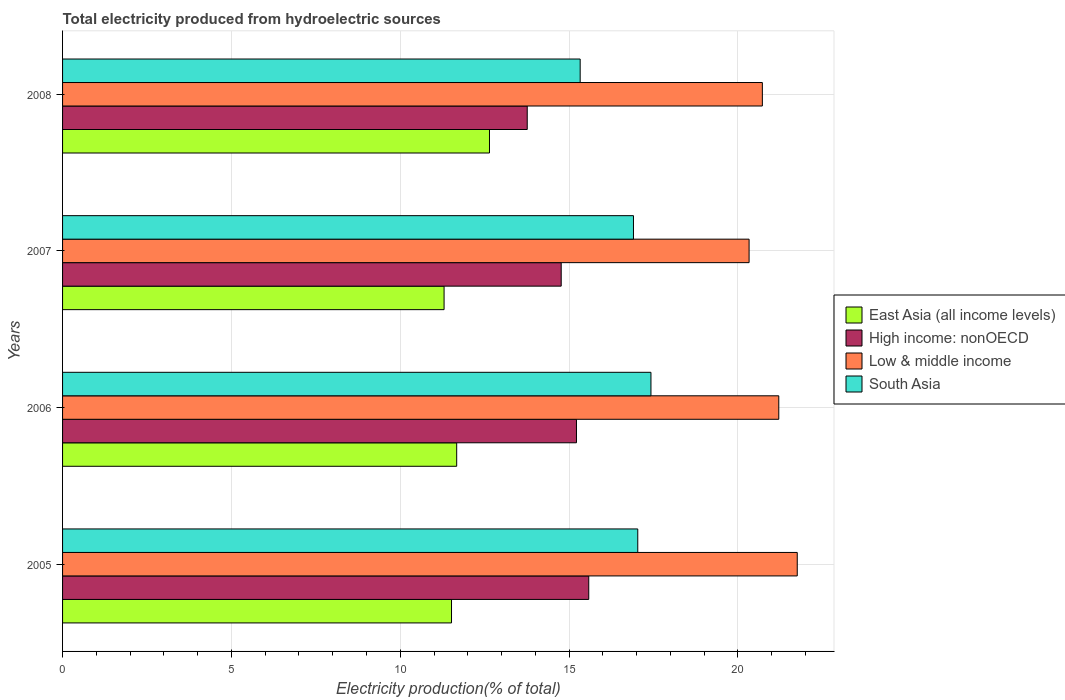How many different coloured bars are there?
Make the answer very short. 4. Are the number of bars per tick equal to the number of legend labels?
Provide a short and direct response. Yes. How many bars are there on the 4th tick from the top?
Keep it short and to the point. 4. How many bars are there on the 4th tick from the bottom?
Make the answer very short. 4. What is the label of the 4th group of bars from the top?
Your answer should be compact. 2005. In how many cases, is the number of bars for a given year not equal to the number of legend labels?
Keep it short and to the point. 0. What is the total electricity produced in South Asia in 2007?
Your answer should be compact. 16.91. Across all years, what is the maximum total electricity produced in South Asia?
Give a very brief answer. 17.43. Across all years, what is the minimum total electricity produced in Low & middle income?
Your answer should be compact. 20.33. In which year was the total electricity produced in Low & middle income maximum?
Ensure brevity in your answer.  2005. In which year was the total electricity produced in High income: nonOECD minimum?
Make the answer very short. 2008. What is the total total electricity produced in South Asia in the graph?
Ensure brevity in your answer.  66.7. What is the difference between the total electricity produced in East Asia (all income levels) in 2005 and that in 2006?
Ensure brevity in your answer.  -0.15. What is the difference between the total electricity produced in High income: nonOECD in 2006 and the total electricity produced in East Asia (all income levels) in 2005?
Provide a succinct answer. 3.7. What is the average total electricity produced in East Asia (all income levels) per year?
Make the answer very short. 11.78. In the year 2005, what is the difference between the total electricity produced in South Asia and total electricity produced in East Asia (all income levels)?
Make the answer very short. 5.52. In how many years, is the total electricity produced in Low & middle income greater than 13 %?
Provide a succinct answer. 4. What is the ratio of the total electricity produced in East Asia (all income levels) in 2005 to that in 2008?
Keep it short and to the point. 0.91. Is the total electricity produced in High income: nonOECD in 2007 less than that in 2008?
Make the answer very short. No. What is the difference between the highest and the second highest total electricity produced in Low & middle income?
Your answer should be compact. 0.55. What is the difference between the highest and the lowest total electricity produced in High income: nonOECD?
Offer a very short reply. 1.82. Is it the case that in every year, the sum of the total electricity produced in East Asia (all income levels) and total electricity produced in High income: nonOECD is greater than the sum of total electricity produced in South Asia and total electricity produced in Low & middle income?
Your response must be concise. Yes. What does the 4th bar from the top in 2005 represents?
Provide a short and direct response. East Asia (all income levels). How many bars are there?
Make the answer very short. 16. Are all the bars in the graph horizontal?
Provide a short and direct response. Yes. What is the difference between two consecutive major ticks on the X-axis?
Provide a succinct answer. 5. Are the values on the major ticks of X-axis written in scientific E-notation?
Provide a succinct answer. No. Where does the legend appear in the graph?
Your response must be concise. Center right. What is the title of the graph?
Keep it short and to the point. Total electricity produced from hydroelectric sources. What is the Electricity production(% of total) of East Asia (all income levels) in 2005?
Provide a succinct answer. 11.52. What is the Electricity production(% of total) in High income: nonOECD in 2005?
Make the answer very short. 15.58. What is the Electricity production(% of total) of Low & middle income in 2005?
Your answer should be very brief. 21.76. What is the Electricity production(% of total) in South Asia in 2005?
Offer a terse response. 17.04. What is the Electricity production(% of total) in East Asia (all income levels) in 2006?
Provide a short and direct response. 11.67. What is the Electricity production(% of total) of High income: nonOECD in 2006?
Offer a terse response. 15.22. What is the Electricity production(% of total) of Low & middle income in 2006?
Provide a succinct answer. 21.21. What is the Electricity production(% of total) of South Asia in 2006?
Offer a very short reply. 17.43. What is the Electricity production(% of total) of East Asia (all income levels) in 2007?
Give a very brief answer. 11.3. What is the Electricity production(% of total) of High income: nonOECD in 2007?
Provide a succinct answer. 14.77. What is the Electricity production(% of total) in Low & middle income in 2007?
Offer a very short reply. 20.33. What is the Electricity production(% of total) of South Asia in 2007?
Your answer should be very brief. 16.91. What is the Electricity production(% of total) of East Asia (all income levels) in 2008?
Keep it short and to the point. 12.64. What is the Electricity production(% of total) in High income: nonOECD in 2008?
Your answer should be compact. 13.76. What is the Electricity production(% of total) of Low & middle income in 2008?
Your answer should be very brief. 20.72. What is the Electricity production(% of total) in South Asia in 2008?
Provide a succinct answer. 15.33. Across all years, what is the maximum Electricity production(% of total) of East Asia (all income levels)?
Provide a succinct answer. 12.64. Across all years, what is the maximum Electricity production(% of total) in High income: nonOECD?
Give a very brief answer. 15.58. Across all years, what is the maximum Electricity production(% of total) in Low & middle income?
Provide a succinct answer. 21.76. Across all years, what is the maximum Electricity production(% of total) of South Asia?
Your answer should be compact. 17.43. Across all years, what is the minimum Electricity production(% of total) of East Asia (all income levels)?
Your response must be concise. 11.3. Across all years, what is the minimum Electricity production(% of total) of High income: nonOECD?
Provide a succinct answer. 13.76. Across all years, what is the minimum Electricity production(% of total) of Low & middle income?
Provide a succinct answer. 20.33. Across all years, what is the minimum Electricity production(% of total) in South Asia?
Your answer should be compact. 15.33. What is the total Electricity production(% of total) of East Asia (all income levels) in the graph?
Give a very brief answer. 47.13. What is the total Electricity production(% of total) in High income: nonOECD in the graph?
Offer a very short reply. 59.33. What is the total Electricity production(% of total) of Low & middle income in the graph?
Provide a succinct answer. 84.03. What is the total Electricity production(% of total) in South Asia in the graph?
Provide a short and direct response. 66.7. What is the difference between the Electricity production(% of total) of East Asia (all income levels) in 2005 and that in 2006?
Ensure brevity in your answer.  -0.15. What is the difference between the Electricity production(% of total) of High income: nonOECD in 2005 and that in 2006?
Your answer should be very brief. 0.36. What is the difference between the Electricity production(% of total) in Low & middle income in 2005 and that in 2006?
Your answer should be compact. 0.55. What is the difference between the Electricity production(% of total) of South Asia in 2005 and that in 2006?
Ensure brevity in your answer.  -0.39. What is the difference between the Electricity production(% of total) in East Asia (all income levels) in 2005 and that in 2007?
Offer a very short reply. 0.22. What is the difference between the Electricity production(% of total) in High income: nonOECD in 2005 and that in 2007?
Give a very brief answer. 0.82. What is the difference between the Electricity production(% of total) in Low & middle income in 2005 and that in 2007?
Provide a short and direct response. 1.43. What is the difference between the Electricity production(% of total) of South Asia in 2005 and that in 2007?
Your answer should be very brief. 0.13. What is the difference between the Electricity production(% of total) of East Asia (all income levels) in 2005 and that in 2008?
Your response must be concise. -1.12. What is the difference between the Electricity production(% of total) of High income: nonOECD in 2005 and that in 2008?
Offer a very short reply. 1.82. What is the difference between the Electricity production(% of total) in Low & middle income in 2005 and that in 2008?
Provide a short and direct response. 1.03. What is the difference between the Electricity production(% of total) of South Asia in 2005 and that in 2008?
Keep it short and to the point. 1.71. What is the difference between the Electricity production(% of total) in East Asia (all income levels) in 2006 and that in 2007?
Your response must be concise. 0.37. What is the difference between the Electricity production(% of total) of High income: nonOECD in 2006 and that in 2007?
Provide a short and direct response. 0.45. What is the difference between the Electricity production(% of total) of Low & middle income in 2006 and that in 2007?
Offer a terse response. 0.88. What is the difference between the Electricity production(% of total) in South Asia in 2006 and that in 2007?
Your response must be concise. 0.52. What is the difference between the Electricity production(% of total) in East Asia (all income levels) in 2006 and that in 2008?
Your answer should be very brief. -0.97. What is the difference between the Electricity production(% of total) in High income: nonOECD in 2006 and that in 2008?
Ensure brevity in your answer.  1.46. What is the difference between the Electricity production(% of total) of Low & middle income in 2006 and that in 2008?
Ensure brevity in your answer.  0.49. What is the difference between the Electricity production(% of total) in South Asia in 2006 and that in 2008?
Ensure brevity in your answer.  2.1. What is the difference between the Electricity production(% of total) in East Asia (all income levels) in 2007 and that in 2008?
Your answer should be compact. -1.34. What is the difference between the Electricity production(% of total) in High income: nonOECD in 2007 and that in 2008?
Offer a terse response. 1.01. What is the difference between the Electricity production(% of total) of Low & middle income in 2007 and that in 2008?
Ensure brevity in your answer.  -0.39. What is the difference between the Electricity production(% of total) in South Asia in 2007 and that in 2008?
Your response must be concise. 1.58. What is the difference between the Electricity production(% of total) of East Asia (all income levels) in 2005 and the Electricity production(% of total) of High income: nonOECD in 2006?
Keep it short and to the point. -3.7. What is the difference between the Electricity production(% of total) of East Asia (all income levels) in 2005 and the Electricity production(% of total) of Low & middle income in 2006?
Provide a short and direct response. -9.69. What is the difference between the Electricity production(% of total) in East Asia (all income levels) in 2005 and the Electricity production(% of total) in South Asia in 2006?
Your answer should be compact. -5.91. What is the difference between the Electricity production(% of total) of High income: nonOECD in 2005 and the Electricity production(% of total) of Low & middle income in 2006?
Your answer should be very brief. -5.63. What is the difference between the Electricity production(% of total) of High income: nonOECD in 2005 and the Electricity production(% of total) of South Asia in 2006?
Your response must be concise. -1.84. What is the difference between the Electricity production(% of total) of Low & middle income in 2005 and the Electricity production(% of total) of South Asia in 2006?
Offer a very short reply. 4.33. What is the difference between the Electricity production(% of total) in East Asia (all income levels) in 2005 and the Electricity production(% of total) in High income: nonOECD in 2007?
Provide a short and direct response. -3.25. What is the difference between the Electricity production(% of total) in East Asia (all income levels) in 2005 and the Electricity production(% of total) in Low & middle income in 2007?
Offer a very short reply. -8.81. What is the difference between the Electricity production(% of total) of East Asia (all income levels) in 2005 and the Electricity production(% of total) of South Asia in 2007?
Ensure brevity in your answer.  -5.39. What is the difference between the Electricity production(% of total) of High income: nonOECD in 2005 and the Electricity production(% of total) of Low & middle income in 2007?
Your answer should be very brief. -4.75. What is the difference between the Electricity production(% of total) of High income: nonOECD in 2005 and the Electricity production(% of total) of South Asia in 2007?
Your answer should be compact. -1.32. What is the difference between the Electricity production(% of total) of Low & middle income in 2005 and the Electricity production(% of total) of South Asia in 2007?
Keep it short and to the point. 4.85. What is the difference between the Electricity production(% of total) of East Asia (all income levels) in 2005 and the Electricity production(% of total) of High income: nonOECD in 2008?
Your response must be concise. -2.24. What is the difference between the Electricity production(% of total) of East Asia (all income levels) in 2005 and the Electricity production(% of total) of Low & middle income in 2008?
Provide a succinct answer. -9.21. What is the difference between the Electricity production(% of total) in East Asia (all income levels) in 2005 and the Electricity production(% of total) in South Asia in 2008?
Your answer should be compact. -3.81. What is the difference between the Electricity production(% of total) of High income: nonOECD in 2005 and the Electricity production(% of total) of Low & middle income in 2008?
Ensure brevity in your answer.  -5.14. What is the difference between the Electricity production(% of total) of High income: nonOECD in 2005 and the Electricity production(% of total) of South Asia in 2008?
Your answer should be compact. 0.25. What is the difference between the Electricity production(% of total) of Low & middle income in 2005 and the Electricity production(% of total) of South Asia in 2008?
Your answer should be compact. 6.43. What is the difference between the Electricity production(% of total) in East Asia (all income levels) in 2006 and the Electricity production(% of total) in High income: nonOECD in 2007?
Your response must be concise. -3.1. What is the difference between the Electricity production(% of total) in East Asia (all income levels) in 2006 and the Electricity production(% of total) in Low & middle income in 2007?
Keep it short and to the point. -8.66. What is the difference between the Electricity production(% of total) in East Asia (all income levels) in 2006 and the Electricity production(% of total) in South Asia in 2007?
Offer a terse response. -5.24. What is the difference between the Electricity production(% of total) of High income: nonOECD in 2006 and the Electricity production(% of total) of Low & middle income in 2007?
Keep it short and to the point. -5.11. What is the difference between the Electricity production(% of total) of High income: nonOECD in 2006 and the Electricity production(% of total) of South Asia in 2007?
Make the answer very short. -1.69. What is the difference between the Electricity production(% of total) in Low & middle income in 2006 and the Electricity production(% of total) in South Asia in 2007?
Provide a short and direct response. 4.3. What is the difference between the Electricity production(% of total) of East Asia (all income levels) in 2006 and the Electricity production(% of total) of High income: nonOECD in 2008?
Ensure brevity in your answer.  -2.09. What is the difference between the Electricity production(% of total) in East Asia (all income levels) in 2006 and the Electricity production(% of total) in Low & middle income in 2008?
Provide a short and direct response. -9.05. What is the difference between the Electricity production(% of total) of East Asia (all income levels) in 2006 and the Electricity production(% of total) of South Asia in 2008?
Provide a succinct answer. -3.66. What is the difference between the Electricity production(% of total) of High income: nonOECD in 2006 and the Electricity production(% of total) of Low & middle income in 2008?
Your answer should be very brief. -5.5. What is the difference between the Electricity production(% of total) of High income: nonOECD in 2006 and the Electricity production(% of total) of South Asia in 2008?
Offer a very short reply. -0.11. What is the difference between the Electricity production(% of total) in Low & middle income in 2006 and the Electricity production(% of total) in South Asia in 2008?
Provide a short and direct response. 5.88. What is the difference between the Electricity production(% of total) of East Asia (all income levels) in 2007 and the Electricity production(% of total) of High income: nonOECD in 2008?
Keep it short and to the point. -2.46. What is the difference between the Electricity production(% of total) of East Asia (all income levels) in 2007 and the Electricity production(% of total) of Low & middle income in 2008?
Give a very brief answer. -9.43. What is the difference between the Electricity production(% of total) in East Asia (all income levels) in 2007 and the Electricity production(% of total) in South Asia in 2008?
Give a very brief answer. -4.03. What is the difference between the Electricity production(% of total) of High income: nonOECD in 2007 and the Electricity production(% of total) of Low & middle income in 2008?
Your response must be concise. -5.96. What is the difference between the Electricity production(% of total) in High income: nonOECD in 2007 and the Electricity production(% of total) in South Asia in 2008?
Provide a short and direct response. -0.56. What is the difference between the Electricity production(% of total) of Low & middle income in 2007 and the Electricity production(% of total) of South Asia in 2008?
Your answer should be very brief. 5. What is the average Electricity production(% of total) in East Asia (all income levels) per year?
Your answer should be very brief. 11.78. What is the average Electricity production(% of total) of High income: nonOECD per year?
Offer a terse response. 14.83. What is the average Electricity production(% of total) of Low & middle income per year?
Ensure brevity in your answer.  21.01. What is the average Electricity production(% of total) of South Asia per year?
Your answer should be very brief. 16.67. In the year 2005, what is the difference between the Electricity production(% of total) in East Asia (all income levels) and Electricity production(% of total) in High income: nonOECD?
Provide a succinct answer. -4.06. In the year 2005, what is the difference between the Electricity production(% of total) in East Asia (all income levels) and Electricity production(% of total) in Low & middle income?
Your answer should be compact. -10.24. In the year 2005, what is the difference between the Electricity production(% of total) in East Asia (all income levels) and Electricity production(% of total) in South Asia?
Make the answer very short. -5.52. In the year 2005, what is the difference between the Electricity production(% of total) of High income: nonOECD and Electricity production(% of total) of Low & middle income?
Your response must be concise. -6.18. In the year 2005, what is the difference between the Electricity production(% of total) in High income: nonOECD and Electricity production(% of total) in South Asia?
Provide a short and direct response. -1.45. In the year 2005, what is the difference between the Electricity production(% of total) in Low & middle income and Electricity production(% of total) in South Asia?
Your response must be concise. 4.72. In the year 2006, what is the difference between the Electricity production(% of total) in East Asia (all income levels) and Electricity production(% of total) in High income: nonOECD?
Give a very brief answer. -3.55. In the year 2006, what is the difference between the Electricity production(% of total) in East Asia (all income levels) and Electricity production(% of total) in Low & middle income?
Offer a very short reply. -9.54. In the year 2006, what is the difference between the Electricity production(% of total) of East Asia (all income levels) and Electricity production(% of total) of South Asia?
Offer a very short reply. -5.75. In the year 2006, what is the difference between the Electricity production(% of total) of High income: nonOECD and Electricity production(% of total) of Low & middle income?
Your response must be concise. -5.99. In the year 2006, what is the difference between the Electricity production(% of total) of High income: nonOECD and Electricity production(% of total) of South Asia?
Your answer should be compact. -2.21. In the year 2006, what is the difference between the Electricity production(% of total) of Low & middle income and Electricity production(% of total) of South Asia?
Your response must be concise. 3.79. In the year 2007, what is the difference between the Electricity production(% of total) in East Asia (all income levels) and Electricity production(% of total) in High income: nonOECD?
Provide a succinct answer. -3.47. In the year 2007, what is the difference between the Electricity production(% of total) in East Asia (all income levels) and Electricity production(% of total) in Low & middle income?
Offer a terse response. -9.03. In the year 2007, what is the difference between the Electricity production(% of total) of East Asia (all income levels) and Electricity production(% of total) of South Asia?
Your answer should be very brief. -5.61. In the year 2007, what is the difference between the Electricity production(% of total) of High income: nonOECD and Electricity production(% of total) of Low & middle income?
Your response must be concise. -5.56. In the year 2007, what is the difference between the Electricity production(% of total) in High income: nonOECD and Electricity production(% of total) in South Asia?
Keep it short and to the point. -2.14. In the year 2007, what is the difference between the Electricity production(% of total) of Low & middle income and Electricity production(% of total) of South Asia?
Make the answer very short. 3.42. In the year 2008, what is the difference between the Electricity production(% of total) of East Asia (all income levels) and Electricity production(% of total) of High income: nonOECD?
Your answer should be very brief. -1.12. In the year 2008, what is the difference between the Electricity production(% of total) of East Asia (all income levels) and Electricity production(% of total) of Low & middle income?
Offer a terse response. -8.08. In the year 2008, what is the difference between the Electricity production(% of total) of East Asia (all income levels) and Electricity production(% of total) of South Asia?
Provide a succinct answer. -2.69. In the year 2008, what is the difference between the Electricity production(% of total) in High income: nonOECD and Electricity production(% of total) in Low & middle income?
Give a very brief answer. -6.96. In the year 2008, what is the difference between the Electricity production(% of total) in High income: nonOECD and Electricity production(% of total) in South Asia?
Make the answer very short. -1.57. In the year 2008, what is the difference between the Electricity production(% of total) in Low & middle income and Electricity production(% of total) in South Asia?
Make the answer very short. 5.4. What is the ratio of the Electricity production(% of total) in East Asia (all income levels) in 2005 to that in 2006?
Make the answer very short. 0.99. What is the ratio of the Electricity production(% of total) of High income: nonOECD in 2005 to that in 2006?
Provide a short and direct response. 1.02. What is the ratio of the Electricity production(% of total) in Low & middle income in 2005 to that in 2006?
Make the answer very short. 1.03. What is the ratio of the Electricity production(% of total) in South Asia in 2005 to that in 2006?
Offer a terse response. 0.98. What is the ratio of the Electricity production(% of total) of East Asia (all income levels) in 2005 to that in 2007?
Keep it short and to the point. 1.02. What is the ratio of the Electricity production(% of total) of High income: nonOECD in 2005 to that in 2007?
Offer a very short reply. 1.06. What is the ratio of the Electricity production(% of total) in Low & middle income in 2005 to that in 2007?
Ensure brevity in your answer.  1.07. What is the ratio of the Electricity production(% of total) in South Asia in 2005 to that in 2007?
Ensure brevity in your answer.  1.01. What is the ratio of the Electricity production(% of total) of East Asia (all income levels) in 2005 to that in 2008?
Offer a very short reply. 0.91. What is the ratio of the Electricity production(% of total) of High income: nonOECD in 2005 to that in 2008?
Ensure brevity in your answer.  1.13. What is the ratio of the Electricity production(% of total) of Low & middle income in 2005 to that in 2008?
Your response must be concise. 1.05. What is the ratio of the Electricity production(% of total) of South Asia in 2005 to that in 2008?
Your response must be concise. 1.11. What is the ratio of the Electricity production(% of total) of East Asia (all income levels) in 2006 to that in 2007?
Offer a terse response. 1.03. What is the ratio of the Electricity production(% of total) of High income: nonOECD in 2006 to that in 2007?
Offer a terse response. 1.03. What is the ratio of the Electricity production(% of total) in Low & middle income in 2006 to that in 2007?
Make the answer very short. 1.04. What is the ratio of the Electricity production(% of total) of South Asia in 2006 to that in 2007?
Make the answer very short. 1.03. What is the ratio of the Electricity production(% of total) of East Asia (all income levels) in 2006 to that in 2008?
Offer a terse response. 0.92. What is the ratio of the Electricity production(% of total) in High income: nonOECD in 2006 to that in 2008?
Your answer should be compact. 1.11. What is the ratio of the Electricity production(% of total) of Low & middle income in 2006 to that in 2008?
Provide a succinct answer. 1.02. What is the ratio of the Electricity production(% of total) in South Asia in 2006 to that in 2008?
Keep it short and to the point. 1.14. What is the ratio of the Electricity production(% of total) in East Asia (all income levels) in 2007 to that in 2008?
Your response must be concise. 0.89. What is the ratio of the Electricity production(% of total) in High income: nonOECD in 2007 to that in 2008?
Ensure brevity in your answer.  1.07. What is the ratio of the Electricity production(% of total) of Low & middle income in 2007 to that in 2008?
Provide a short and direct response. 0.98. What is the ratio of the Electricity production(% of total) of South Asia in 2007 to that in 2008?
Offer a very short reply. 1.1. What is the difference between the highest and the second highest Electricity production(% of total) of East Asia (all income levels)?
Your answer should be very brief. 0.97. What is the difference between the highest and the second highest Electricity production(% of total) of High income: nonOECD?
Your answer should be very brief. 0.36. What is the difference between the highest and the second highest Electricity production(% of total) in Low & middle income?
Your response must be concise. 0.55. What is the difference between the highest and the second highest Electricity production(% of total) of South Asia?
Your response must be concise. 0.39. What is the difference between the highest and the lowest Electricity production(% of total) of East Asia (all income levels)?
Your response must be concise. 1.34. What is the difference between the highest and the lowest Electricity production(% of total) of High income: nonOECD?
Ensure brevity in your answer.  1.82. What is the difference between the highest and the lowest Electricity production(% of total) in Low & middle income?
Keep it short and to the point. 1.43. What is the difference between the highest and the lowest Electricity production(% of total) of South Asia?
Ensure brevity in your answer.  2.1. 